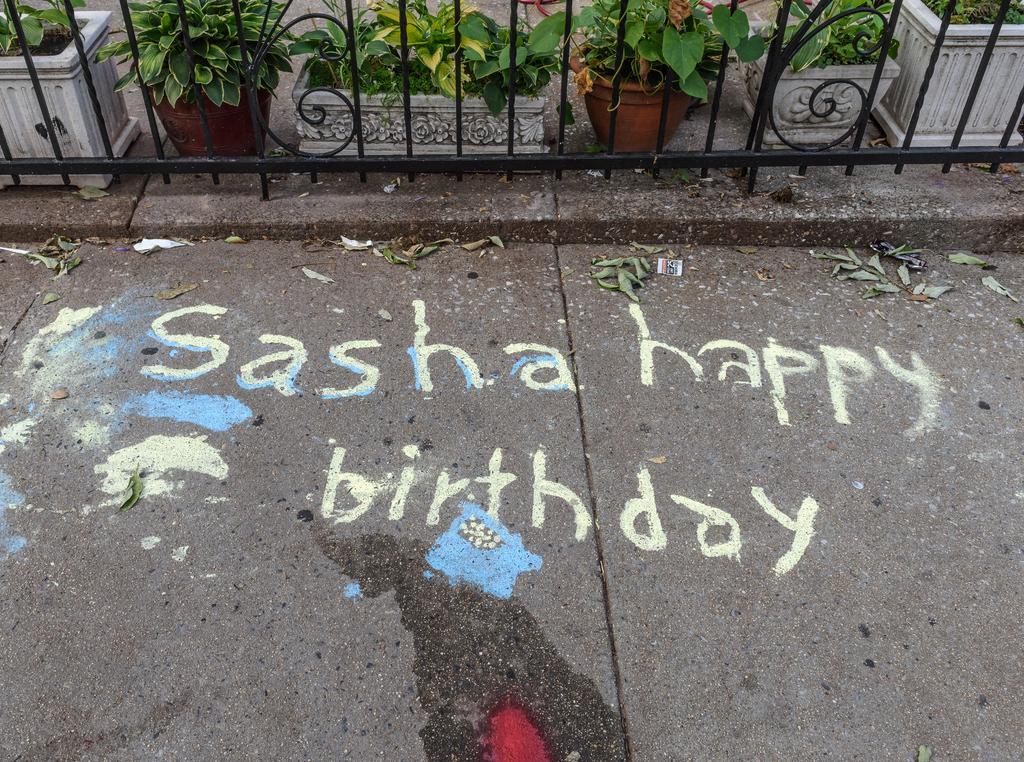In one or two sentences, can you explain what this image depicts? In this picture we can see some text and a few dry leaves on the path. There is water and colorful things seen on the path. We can see a fence. Behind the fence, we can see some flower pots in the background. 